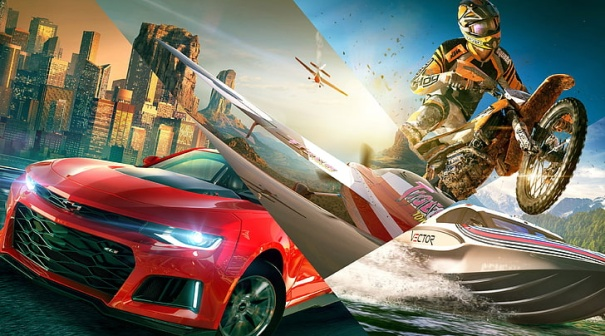Can you describe the main features of this image for me? In the dynamic image, a captivating scene features a vibrant mix of action and urban elements. On the left side, a striking red sports car stands out, enhanced by the gleaming silver sword design on its hood, creating a sense of motion as it faces towards the right. To the right, an adrenaline-fueled moment is captured with a dirt bike rider performing a mid-air jump. The rider's yellow and black helmet adds a bright splash of color against the urban backdrop. Notably, above them, two helicopters hover, potentially surveying the thrilling activities below. The scene is set against a city skyline of towering buildings, which transitions into a landscape of distant mountains under a clear blue sky scattered with fluffy clouds. This image artfully blends city life, adventure, and the thrill of extreme sports into a single, dynamic narrative. 